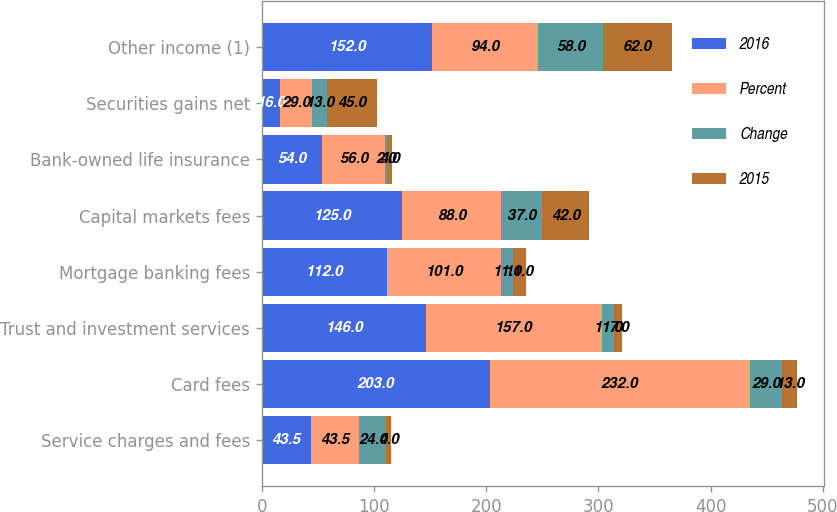Convert chart. <chart><loc_0><loc_0><loc_500><loc_500><stacked_bar_chart><ecel><fcel>Service charges and fees<fcel>Card fees<fcel>Trust and investment services<fcel>Mortgage banking fees<fcel>Capital markets fees<fcel>Bank-owned life insurance<fcel>Securities gains net<fcel>Other income (1)<nl><fcel>2016<fcel>43.5<fcel>203<fcel>146<fcel>112<fcel>125<fcel>54<fcel>16<fcel>152<nl><fcel>Percent<fcel>43.5<fcel>232<fcel>157<fcel>101<fcel>88<fcel>56<fcel>29<fcel>94<nl><fcel>Change<fcel>24<fcel>29<fcel>11<fcel>11<fcel>37<fcel>2<fcel>13<fcel>58<nl><fcel>2015<fcel>4<fcel>13<fcel>7<fcel>11<fcel>42<fcel>4<fcel>45<fcel>62<nl></chart> 